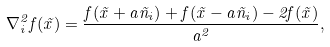Convert formula to latex. <formula><loc_0><loc_0><loc_500><loc_500>\nabla _ { i } ^ { 2 } f ( \vec { x } ) = \frac { f ( \vec { x } + a \vec { n } _ { i } ) + f ( \vec { x } - a \vec { n } _ { i } ) - 2 f ( \vec { x } ) } { a ^ { 2 } } ,</formula> 